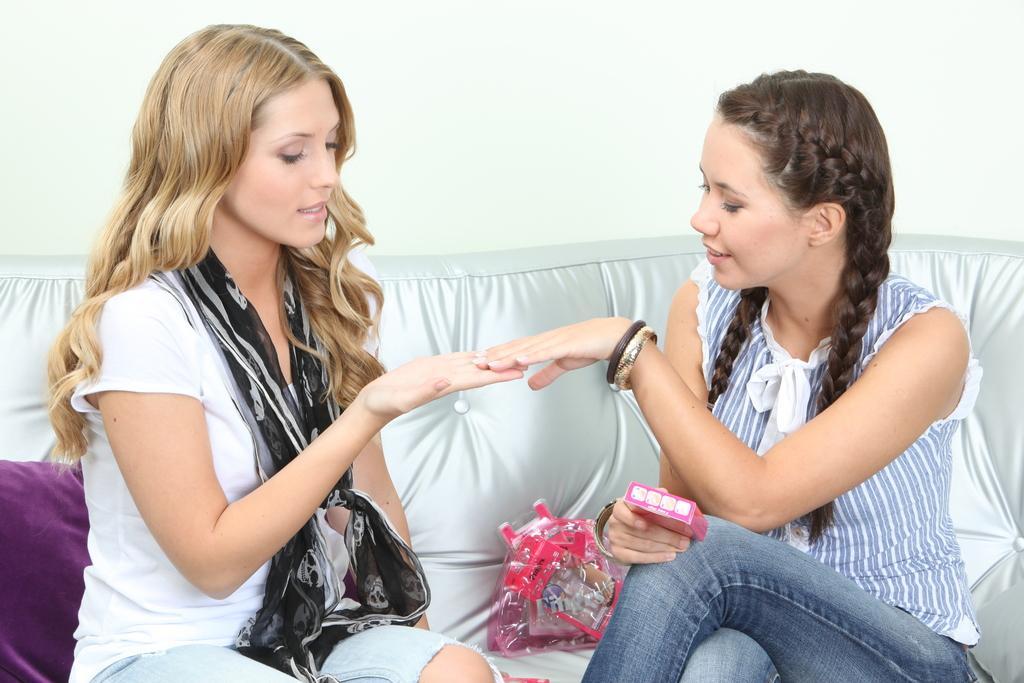Please provide a concise description of this image. In this picture we can see there are two women sitting on a couch and a woman is holding an object and on the couch there is a cushion and some things. Behind the people there is a wall. 